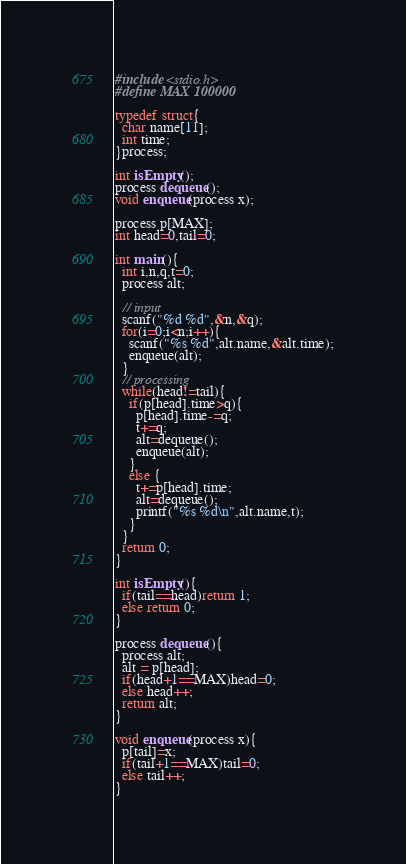Convert code to text. <code><loc_0><loc_0><loc_500><loc_500><_C_>#include <stdio.h>
#define MAX 100000

typedef struct{
  char name[11];
  int time;
}process;

int isEmpty();
process dequeue();
void enqueue(process x);

process p[MAX];
int head=0,tail=0;

int main(){
  int i,n,q,t=0;
  process alt;

  // input
  scanf("%d %d",&n,&q);
  for(i=0;i<n;i++){
    scanf("%s %d",alt.name,&alt.time);
    enqueue(alt);
  }
  // processing
  while(head!=tail){
    if(p[head].time>q){
      p[head].time-=q;
      t+=q;
      alt=dequeue();
      enqueue(alt);
    }
    else {
      t+=p[head].time;
      alt=dequeue();
      printf("%s %d\n",alt.name,t);
    }
  }  
  return 0;
}

int isEmpty(){
  if(tail==head)return 1;
  else return 0;
}

process dequeue(){
  process alt;
  alt = p[head];
  if(head+1==MAX)head=0;
  else head++;    
  return alt;  
}

void enqueue(process x){
  p[tail]=x;
  if(tail+1==MAX)tail=0;
  else tail++;
}</code> 